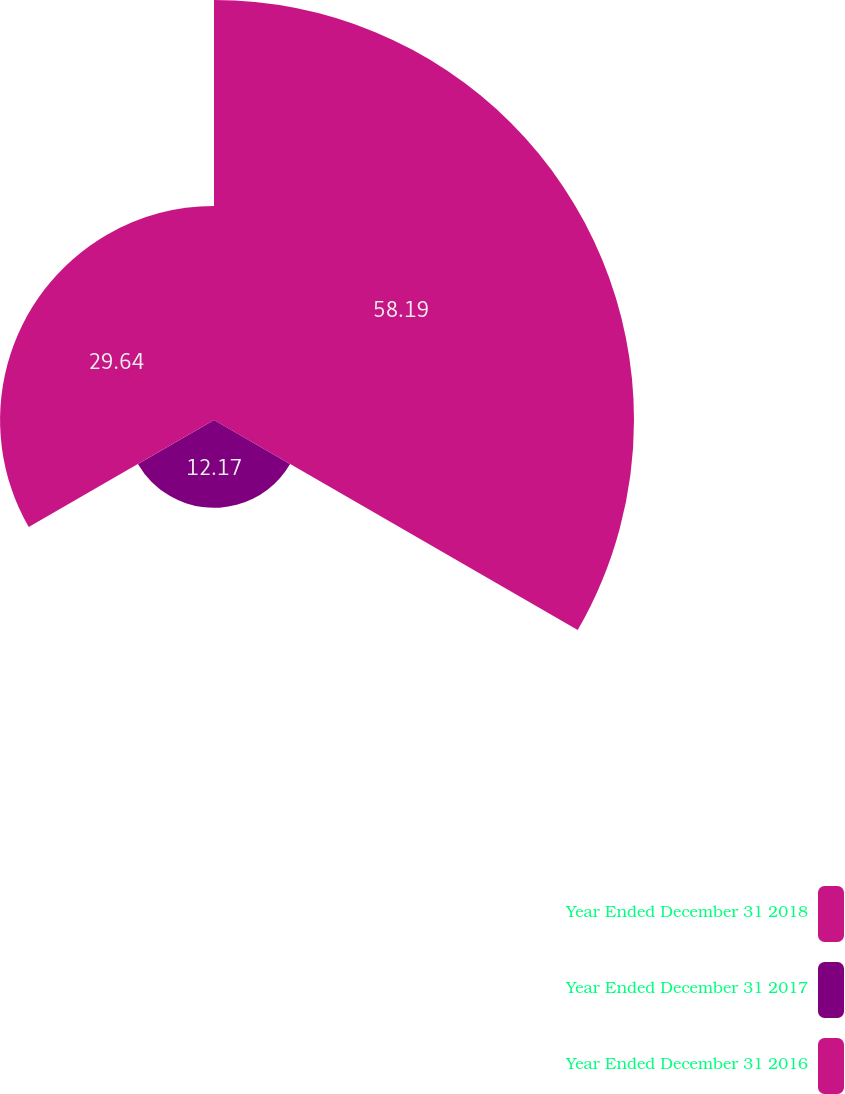<chart> <loc_0><loc_0><loc_500><loc_500><pie_chart><fcel>Year Ended December 31 2018<fcel>Year Ended December 31 2017<fcel>Year Ended December 31 2016<nl><fcel>58.19%<fcel>12.17%<fcel>29.64%<nl></chart> 